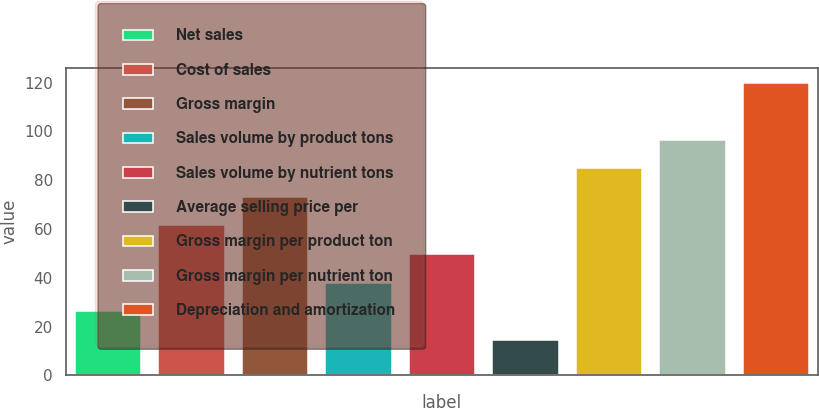<chart> <loc_0><loc_0><loc_500><loc_500><bar_chart><fcel>Net sales<fcel>Cost of sales<fcel>Gross margin<fcel>Sales volume by product tons<fcel>Sales volume by nutrient tons<fcel>Average selling price per<fcel>Gross margin per product ton<fcel>Gross margin per nutrient ton<fcel>Depreciation and amortization<nl><fcel>26.4<fcel>61.5<fcel>73.2<fcel>38.1<fcel>49.8<fcel>14.7<fcel>84.9<fcel>96.6<fcel>120<nl></chart> 